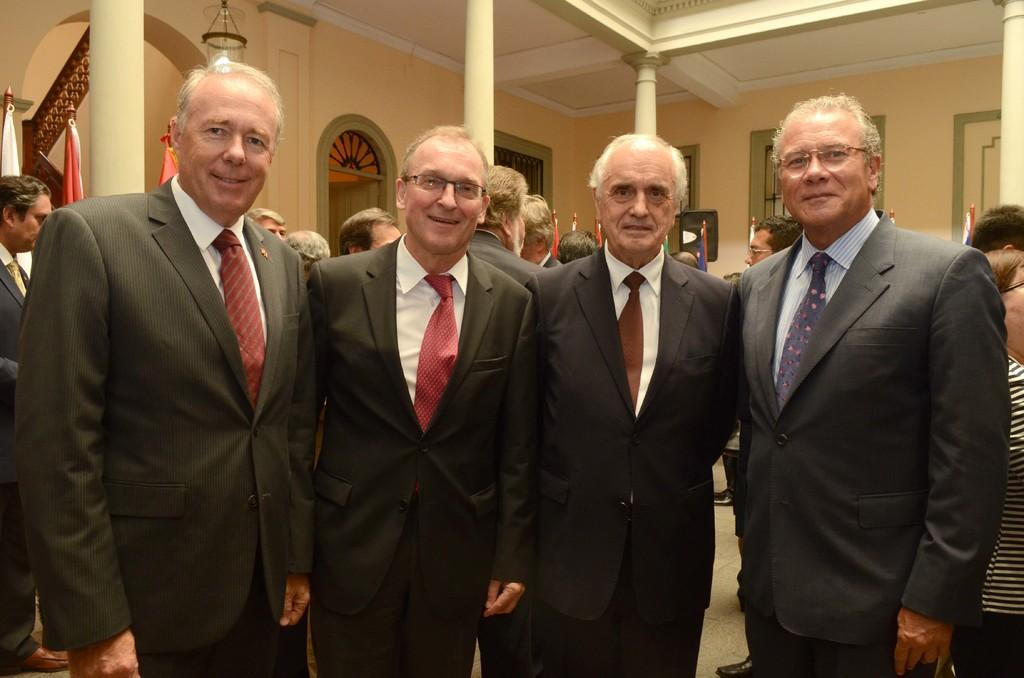What is the main subject of the image? The main subject of the image is a group of persons standing in the center. Where are the persons standing? The persons are standing on the floor. What can be seen in the background of the image? In the background of the image, there are persons, pillars, doors, windows, flags, light, and a wall. What type of banana is being held by the beast in the image? There is no banana or beast present in the image. 